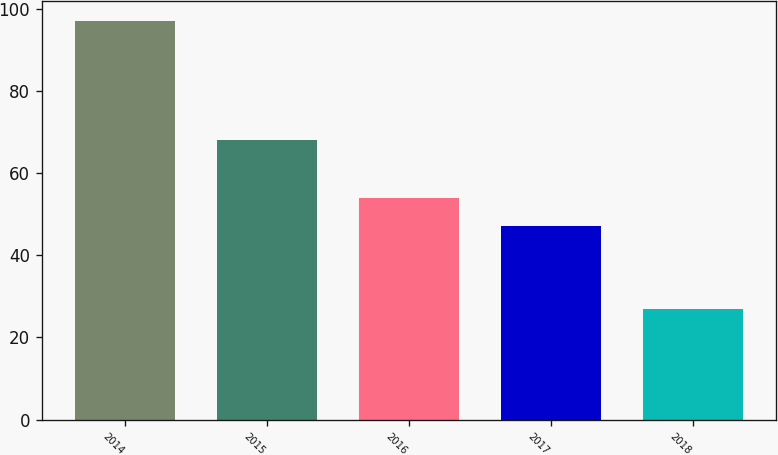<chart> <loc_0><loc_0><loc_500><loc_500><bar_chart><fcel>2014<fcel>2015<fcel>2016<fcel>2017<fcel>2018<nl><fcel>97<fcel>68<fcel>54<fcel>47<fcel>27<nl></chart> 